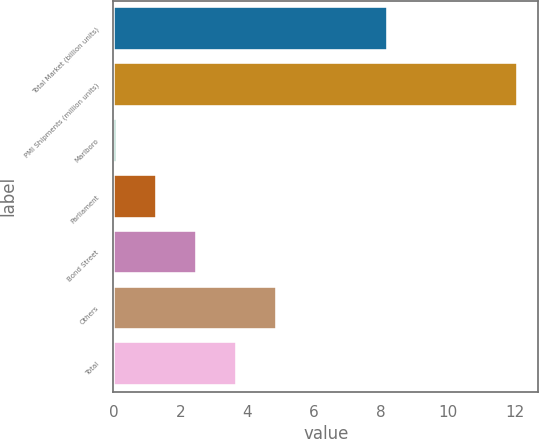<chart> <loc_0><loc_0><loc_500><loc_500><bar_chart><fcel>Total Market (billion units)<fcel>PMI Shipments (million units)<fcel>Marlboro<fcel>Parliament<fcel>Bond Street<fcel>Others<fcel>Total<nl><fcel>8.2<fcel>12.1<fcel>0.1<fcel>1.3<fcel>2.5<fcel>4.9<fcel>3.7<nl></chart> 